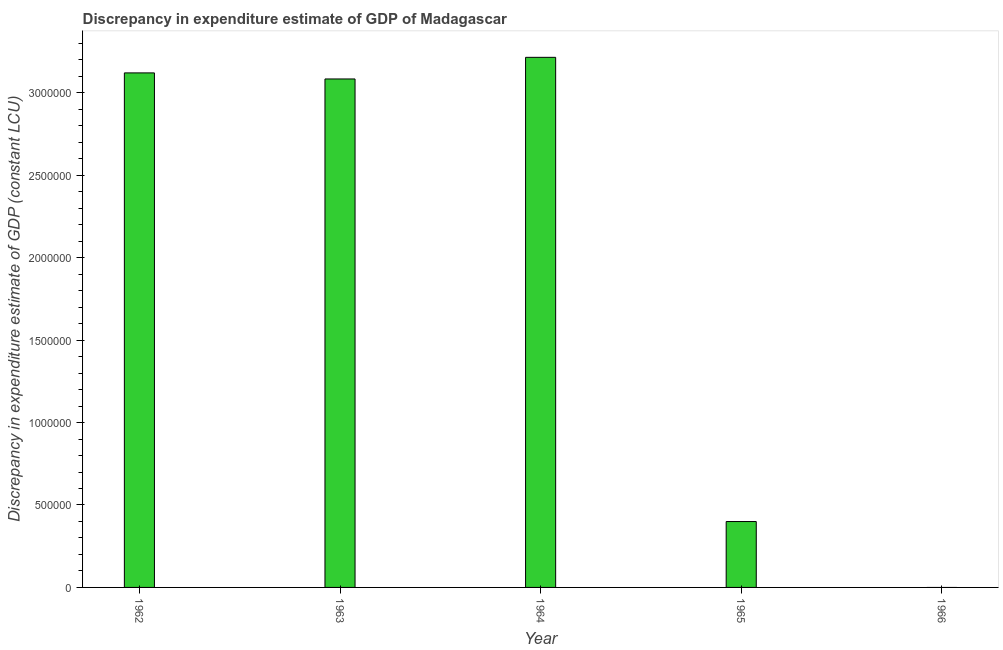Does the graph contain any zero values?
Offer a very short reply. Yes. Does the graph contain grids?
Provide a succinct answer. No. What is the title of the graph?
Make the answer very short. Discrepancy in expenditure estimate of GDP of Madagascar. What is the label or title of the X-axis?
Offer a very short reply. Year. What is the label or title of the Y-axis?
Keep it short and to the point. Discrepancy in expenditure estimate of GDP (constant LCU). What is the discrepancy in expenditure estimate of gdp in 1965?
Your answer should be very brief. 4.00e+05. Across all years, what is the maximum discrepancy in expenditure estimate of gdp?
Your answer should be very brief. 3.22e+06. In which year was the discrepancy in expenditure estimate of gdp maximum?
Ensure brevity in your answer.  1964. What is the sum of the discrepancy in expenditure estimate of gdp?
Provide a succinct answer. 9.82e+06. What is the difference between the discrepancy in expenditure estimate of gdp in 1962 and 1963?
Your response must be concise. 3.68e+04. What is the average discrepancy in expenditure estimate of gdp per year?
Provide a succinct answer. 1.96e+06. What is the median discrepancy in expenditure estimate of gdp?
Your response must be concise. 3.08e+06. What is the ratio of the discrepancy in expenditure estimate of gdp in 1963 to that in 1965?
Make the answer very short. 7.72. Is the discrepancy in expenditure estimate of gdp in 1963 less than that in 1964?
Your response must be concise. Yes. Is the difference between the discrepancy in expenditure estimate of gdp in 1962 and 1963 greater than the difference between any two years?
Offer a very short reply. No. What is the difference between the highest and the second highest discrepancy in expenditure estimate of gdp?
Keep it short and to the point. 9.44e+04. What is the difference between the highest and the lowest discrepancy in expenditure estimate of gdp?
Keep it short and to the point. 3.22e+06. In how many years, is the discrepancy in expenditure estimate of gdp greater than the average discrepancy in expenditure estimate of gdp taken over all years?
Provide a short and direct response. 3. What is the Discrepancy in expenditure estimate of GDP (constant LCU) in 1962?
Your answer should be very brief. 3.12e+06. What is the Discrepancy in expenditure estimate of GDP (constant LCU) in 1963?
Provide a succinct answer. 3.08e+06. What is the Discrepancy in expenditure estimate of GDP (constant LCU) of 1964?
Offer a very short reply. 3.22e+06. What is the Discrepancy in expenditure estimate of GDP (constant LCU) of 1965?
Give a very brief answer. 4.00e+05. What is the Discrepancy in expenditure estimate of GDP (constant LCU) of 1966?
Your answer should be very brief. 0. What is the difference between the Discrepancy in expenditure estimate of GDP (constant LCU) in 1962 and 1963?
Make the answer very short. 3.68e+04. What is the difference between the Discrepancy in expenditure estimate of GDP (constant LCU) in 1962 and 1964?
Give a very brief answer. -9.44e+04. What is the difference between the Discrepancy in expenditure estimate of GDP (constant LCU) in 1962 and 1965?
Keep it short and to the point. 2.72e+06. What is the difference between the Discrepancy in expenditure estimate of GDP (constant LCU) in 1963 and 1964?
Your answer should be very brief. -1.31e+05. What is the difference between the Discrepancy in expenditure estimate of GDP (constant LCU) in 1963 and 1965?
Your answer should be very brief. 2.68e+06. What is the difference between the Discrepancy in expenditure estimate of GDP (constant LCU) in 1964 and 1965?
Your answer should be compact. 2.82e+06. What is the ratio of the Discrepancy in expenditure estimate of GDP (constant LCU) in 1962 to that in 1965?
Your response must be concise. 7.81. What is the ratio of the Discrepancy in expenditure estimate of GDP (constant LCU) in 1963 to that in 1965?
Your response must be concise. 7.72. What is the ratio of the Discrepancy in expenditure estimate of GDP (constant LCU) in 1964 to that in 1965?
Offer a terse response. 8.04. 